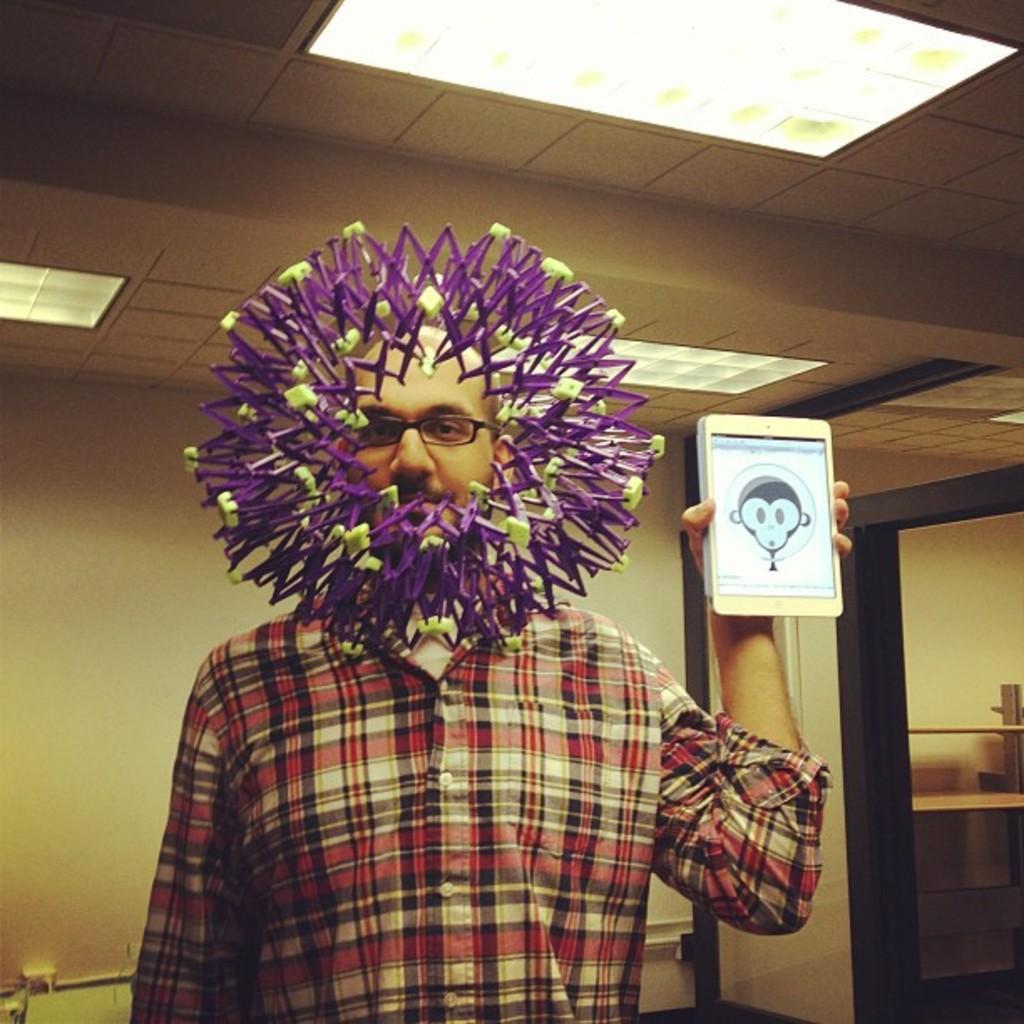Describe this image in one or two sentences. There is a man standing and holding a gadget and wore spectacle,in front of this man we can see decorative object. In the background we can see wall. At the top we can see lights. 